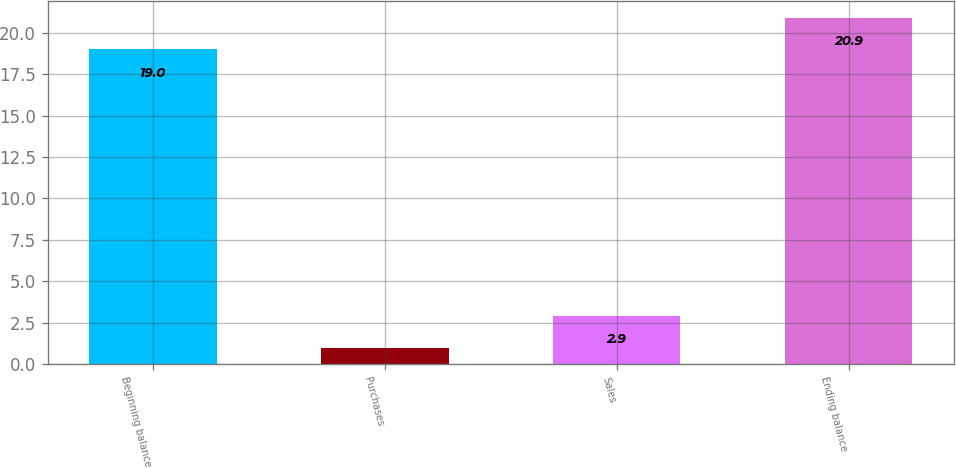Convert chart to OTSL. <chart><loc_0><loc_0><loc_500><loc_500><bar_chart><fcel>Beginning balance<fcel>Purchases<fcel>Sales<fcel>Ending balance<nl><fcel>19<fcel>1<fcel>2.9<fcel>20.9<nl></chart> 